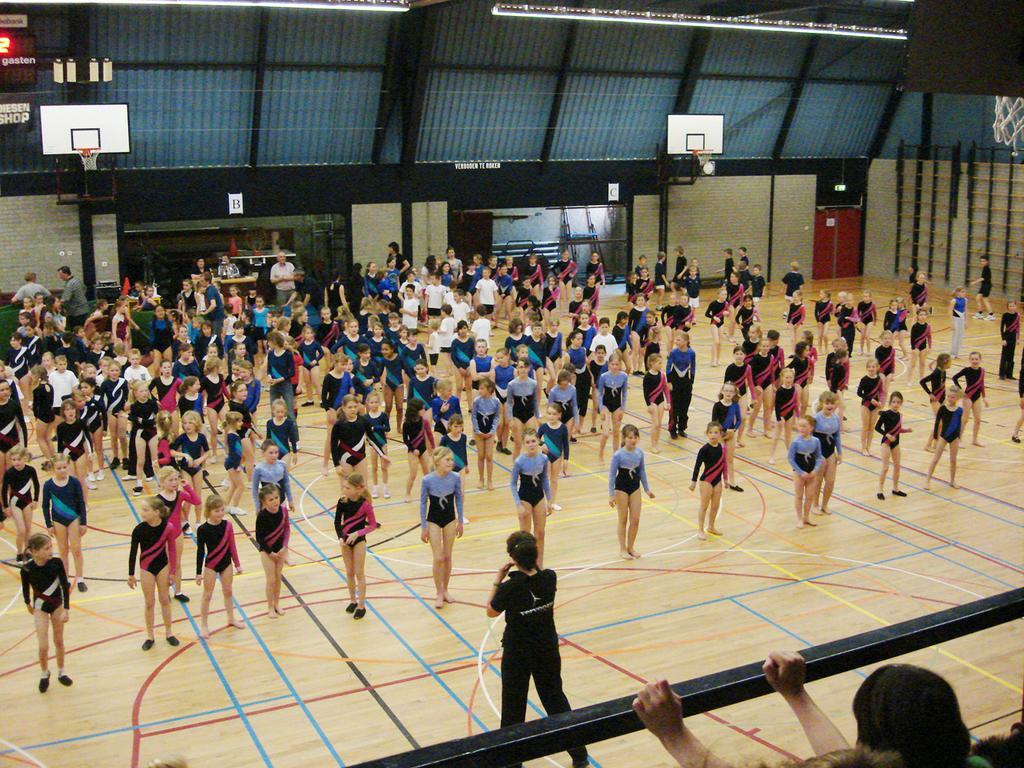In one or two sentences, can you explain what this image depicts? In this image we can see people and there are hoops. At the bottom there is a rod and we can see a door. At the top there are lights. 